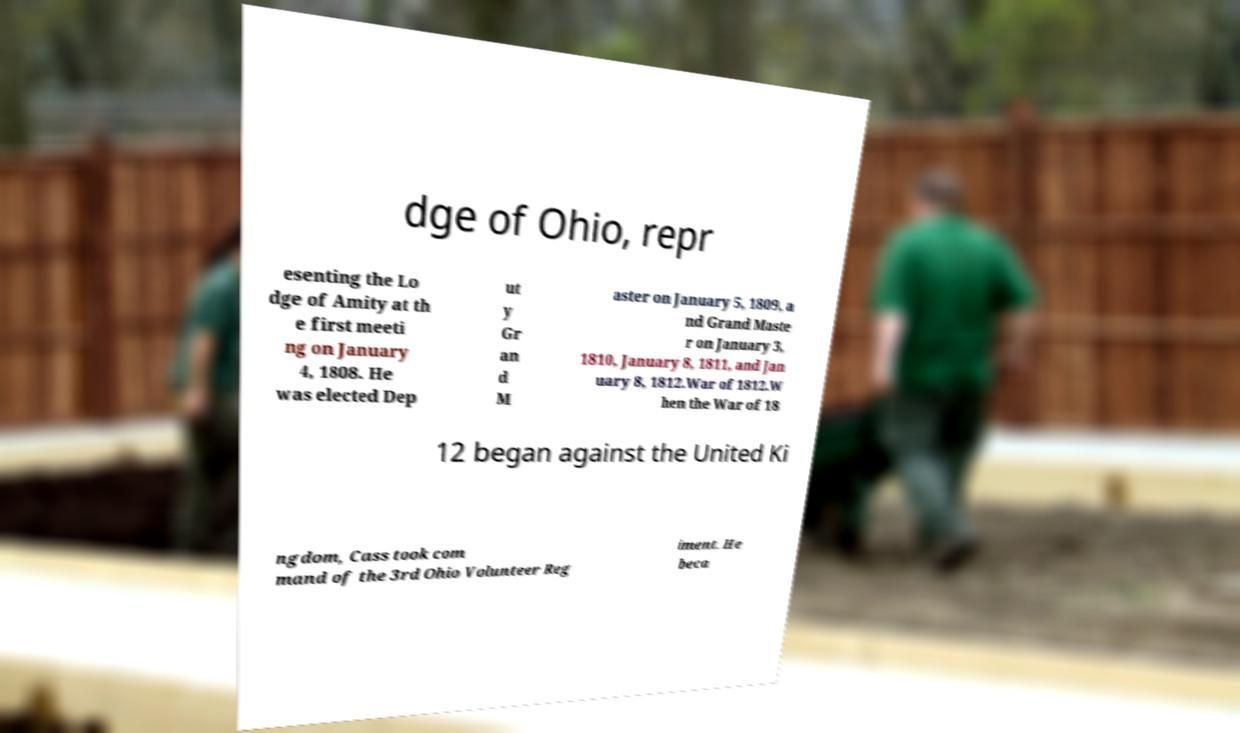Can you accurately transcribe the text from the provided image for me? dge of Ohio, repr esenting the Lo dge of Amity at th e first meeti ng on January 4, 1808. He was elected Dep ut y Gr an d M aster on January 5, 1809, a nd Grand Maste r on January 3, 1810, January 8, 1811, and Jan uary 8, 1812.War of 1812.W hen the War of 18 12 began against the United Ki ngdom, Cass took com mand of the 3rd Ohio Volunteer Reg iment. He beca 